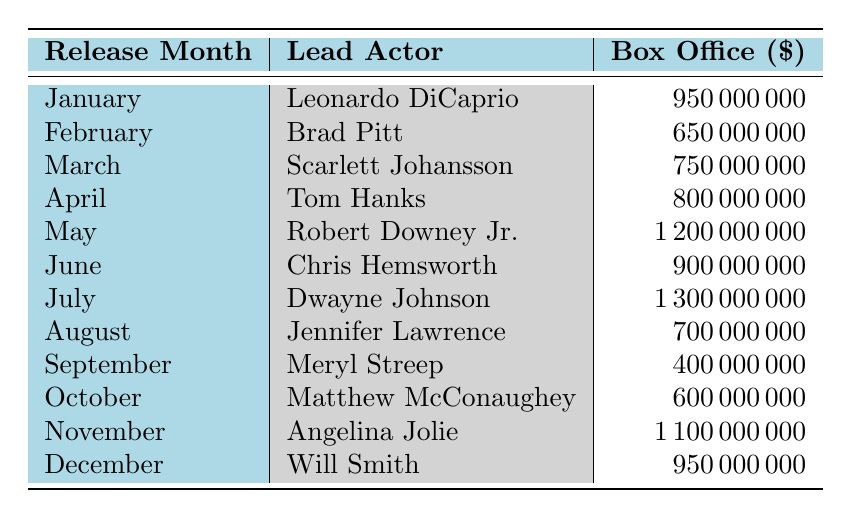What is the highest box office performance among the lead actors? The table shows that Dwayne Johnson's box office performance in July is 1,300,000,000, which is more than any other actor's performance listed for other months.
Answer: 1,300,000,000 Which actor had the lowest box office performance, and in which month? By reviewing the table, Meryl Streep had the lowest performance of 400,000,000, which is listed for September.
Answer: Meryl Streep, September What is the total box office performance for the actors in the first quarter (January to March)? The box office values for January (950,000,000), February (650,000,000), and March (750,000,000) total up to 950 + 650 + 750 = 2,350,000,000.
Answer: 2,350,000,000 Is there an actor who had a box office performance over a billion dollars? Yes, checking the table, Robert Downey Jr., Dwayne Johnson, and Angelina Jolie had performances exceeding a billion (1,200,000,000; 1,300,000,000; and 1,100,000,000 respectively).
Answer: Yes What is the average box office performance of the actors in the second half of the year (July to December)? The box office performances from July to December are: 1,300,000,000 (July), 700,000,000 (August), 400,000,000 (September), 600,000,000 (October), 1,100,000,000 (November), and 950,000,000 (December). Summing these gives 1,300 + 700 + 400 + 600 + 1,100 + 950 = 5,050,000,000. There are 6 data points, so the average is 5,050,000,000 / 6 = 841,666,667.
Answer: 841,666,667 Which month had the highest box office performance? Dwayne Johnson in July had the highest box office of 1,300,000,000, which is the highest figure among all the months listed.
Answer: July 